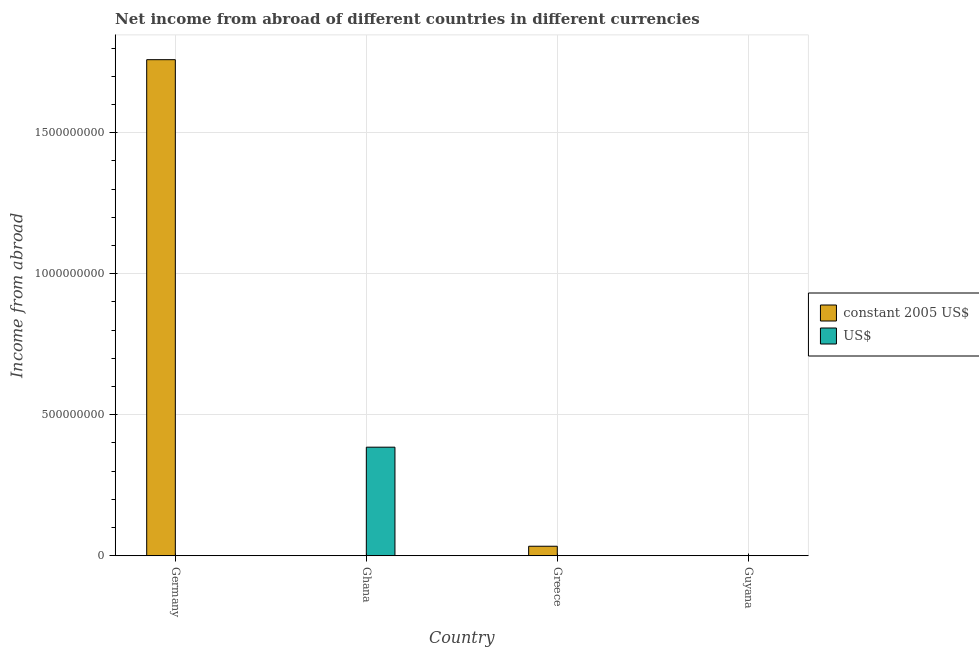Are the number of bars per tick equal to the number of legend labels?
Offer a very short reply. No. Across all countries, what is the maximum income from abroad in us$?
Offer a terse response. 3.85e+08. In which country was the income from abroad in constant 2005 us$ maximum?
Give a very brief answer. Germany. What is the total income from abroad in us$ in the graph?
Offer a terse response. 3.85e+08. What is the difference between the income from abroad in constant 2005 us$ in Germany and that in Greece?
Offer a very short reply. 1.73e+09. What is the average income from abroad in constant 2005 us$ per country?
Make the answer very short. 4.48e+08. In how many countries, is the income from abroad in constant 2005 us$ greater than 1000000000 units?
Offer a very short reply. 1. What is the difference between the highest and the lowest income from abroad in us$?
Your answer should be compact. 3.85e+08. Is the sum of the income from abroad in constant 2005 us$ in Germany and Greece greater than the maximum income from abroad in us$ across all countries?
Offer a terse response. Yes. Are all the bars in the graph horizontal?
Offer a terse response. No. How many countries are there in the graph?
Make the answer very short. 4. What is the difference between two consecutive major ticks on the Y-axis?
Provide a succinct answer. 5.00e+08. Are the values on the major ticks of Y-axis written in scientific E-notation?
Your answer should be compact. No. Does the graph contain any zero values?
Your answer should be very brief. Yes. Does the graph contain grids?
Your answer should be compact. Yes. Where does the legend appear in the graph?
Offer a very short reply. Center right. How are the legend labels stacked?
Make the answer very short. Vertical. What is the title of the graph?
Offer a terse response. Net income from abroad of different countries in different currencies. What is the label or title of the Y-axis?
Your answer should be compact. Income from abroad. What is the Income from abroad in constant 2005 US$ in Germany?
Your answer should be very brief. 1.76e+09. What is the Income from abroad of US$ in Ghana?
Your answer should be compact. 3.85e+08. What is the Income from abroad of constant 2005 US$ in Greece?
Give a very brief answer. 3.39e+07. What is the Income from abroad in constant 2005 US$ in Guyana?
Your response must be concise. 0. Across all countries, what is the maximum Income from abroad in constant 2005 US$?
Your answer should be very brief. 1.76e+09. Across all countries, what is the maximum Income from abroad of US$?
Ensure brevity in your answer.  3.85e+08. Across all countries, what is the minimum Income from abroad in US$?
Provide a succinct answer. 0. What is the total Income from abroad in constant 2005 US$ in the graph?
Keep it short and to the point. 1.79e+09. What is the total Income from abroad in US$ in the graph?
Your answer should be very brief. 3.85e+08. What is the difference between the Income from abroad in constant 2005 US$ in Germany and that in Greece?
Provide a short and direct response. 1.73e+09. What is the difference between the Income from abroad of constant 2005 US$ in Germany and the Income from abroad of US$ in Ghana?
Offer a very short reply. 1.37e+09. What is the average Income from abroad in constant 2005 US$ per country?
Provide a short and direct response. 4.48e+08. What is the average Income from abroad in US$ per country?
Provide a short and direct response. 9.63e+07. What is the ratio of the Income from abroad in constant 2005 US$ in Germany to that in Greece?
Make the answer very short. 51.9. What is the difference between the highest and the lowest Income from abroad of constant 2005 US$?
Your answer should be very brief. 1.76e+09. What is the difference between the highest and the lowest Income from abroad in US$?
Give a very brief answer. 3.85e+08. 